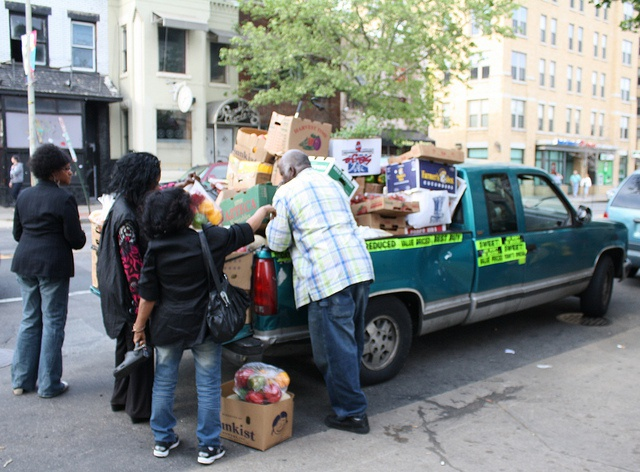Describe the objects in this image and their specific colors. I can see truck in white, black, blue, gray, and darkblue tones, people in white, black, blue, navy, and gray tones, people in white, black, navy, and blue tones, people in white, black, blue, and gray tones, and people in white, black, gray, and darkblue tones in this image. 